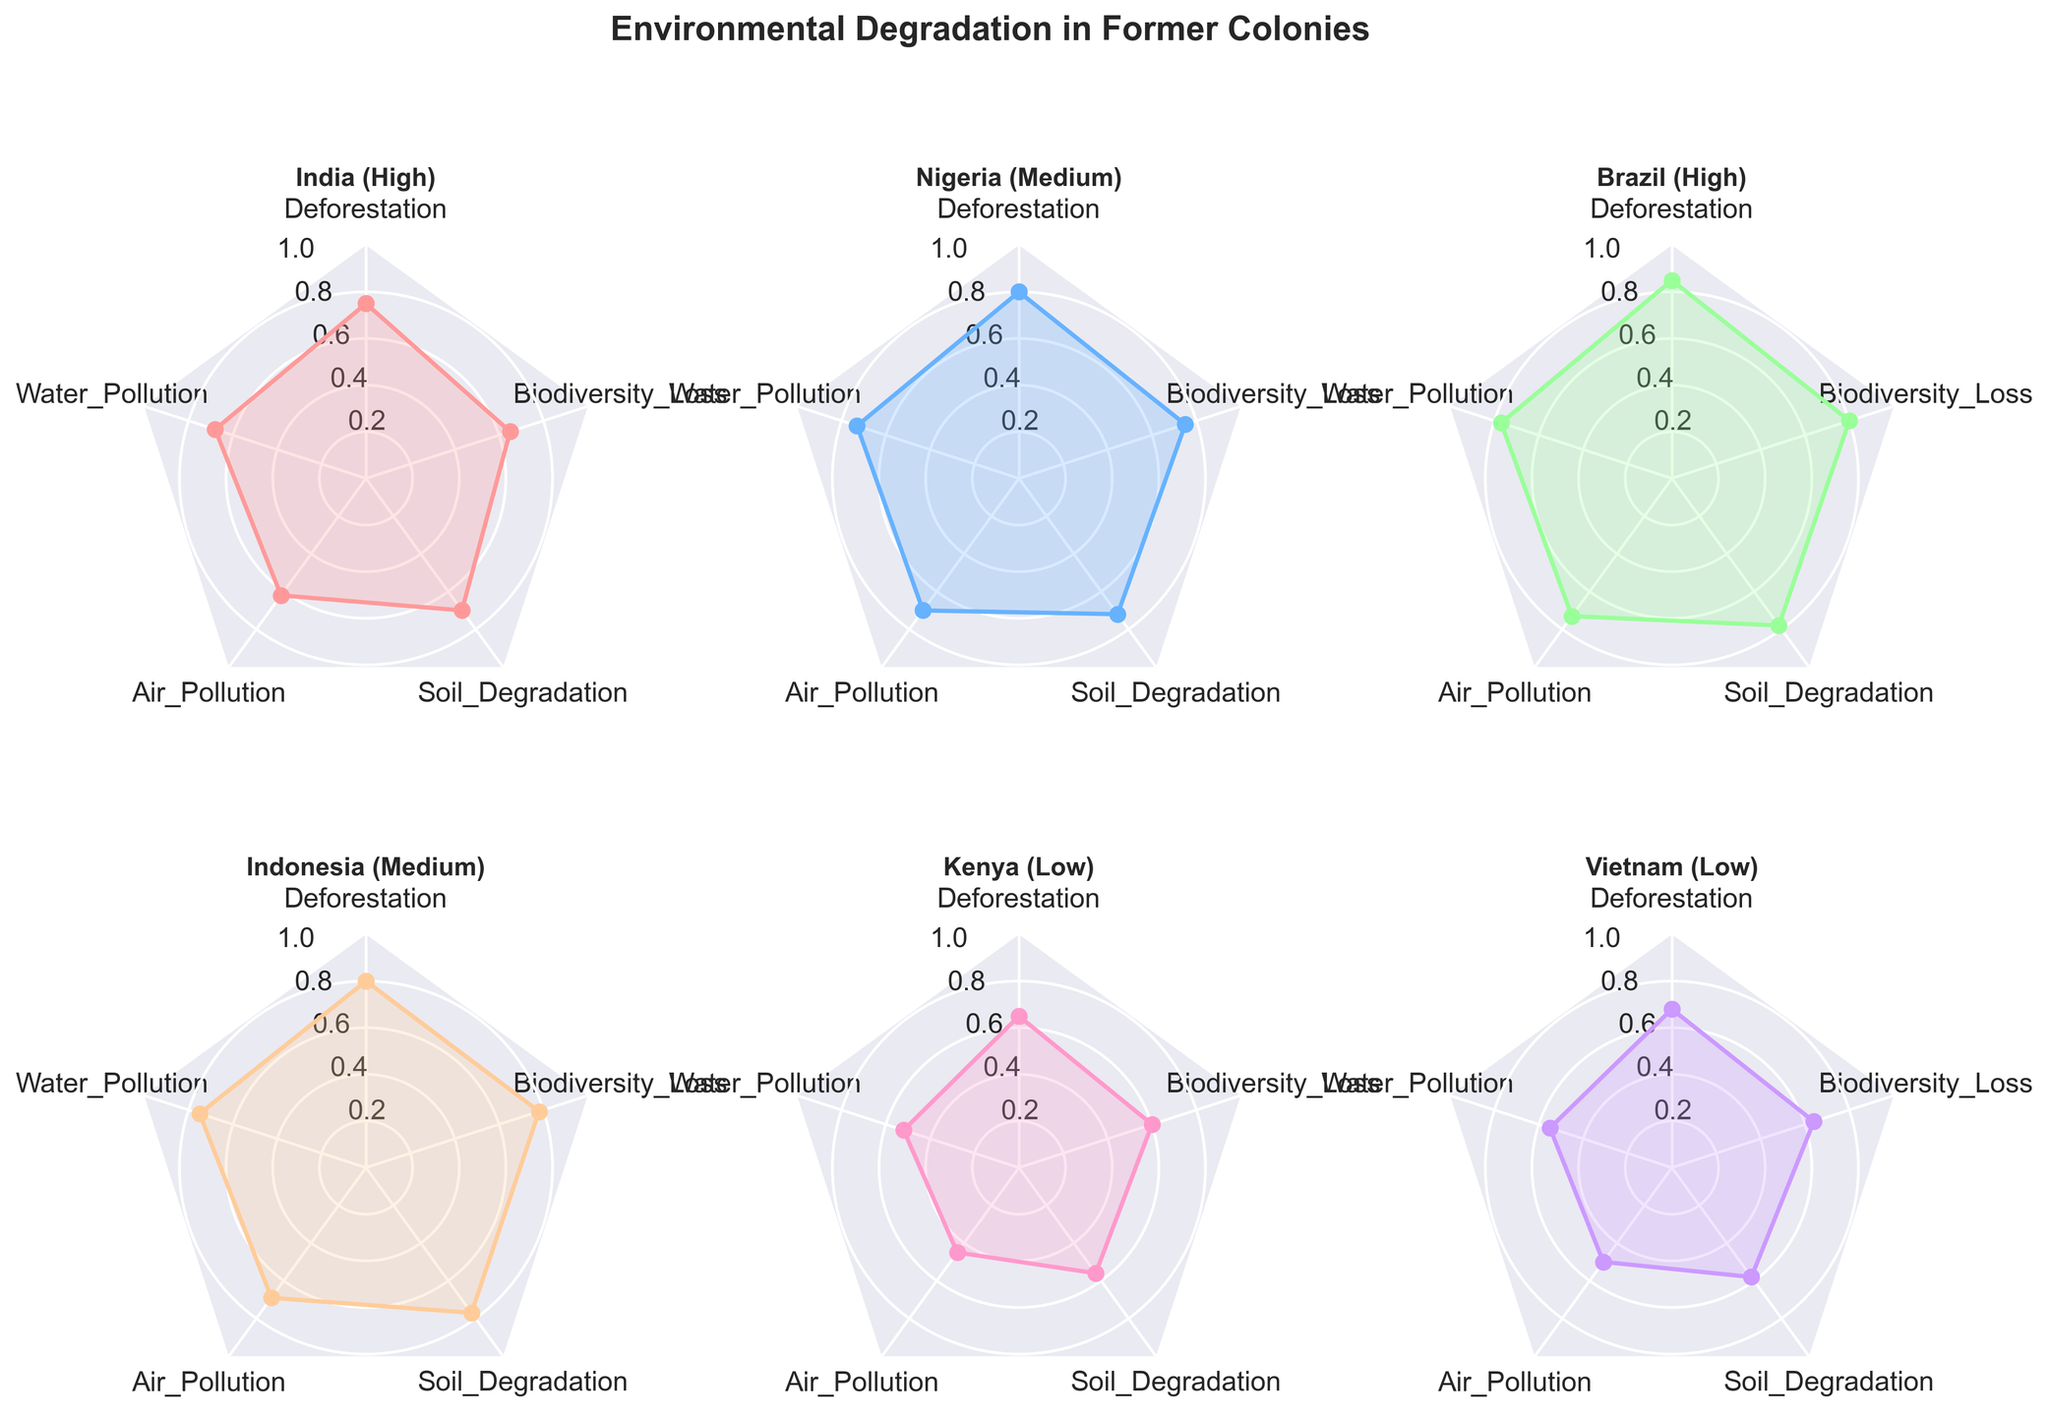Which country has the highest deforestation level? By observing the segments labeled "Deforestation" in the radar charts, the segment with the highest value indicates the highest deforestation level. Brazil has the highest deforestation level at 0.85.
Answer: Brazil Which country and industrialization level combination shows the lowest air pollution levels? Viewing the "Air Pollution" segments across all subplots, Kenya (Low) has the lowest value at 0.45.
Answer: Kenya (Low) What is the average water pollution level for high industrialization level countries? Both India and Brazil are classified under high industrialization. By averaging their water pollution values: (0.68 + 0.77) / 2 = 0.725.
Answer: 0.725 Which country has greater soil degradation, Indonesia or Vietnam? By checking the "Soil Degradation" segments of Indonesia and Vietnam, Indonesia has a higher value at 0.77 compared to Vietnam's 0.58.
Answer: Indonesia Which type of environmental degradation appears most consistently across all countries? By examining the amplitude across all categories in each radar chart, biodiversity loss often shows high values, being consistently problematic across all countries.
Answer: Biodiversity Loss Which country exhibits the widest range between its highest and lowest environmental degradation values? By calculating the range (difference between the highest and lowest values) for each country:
India: 0.75 - 0.62 = 0.13
Nigeria: 0.80 - 0.70 = 0.10
Brazil: 0.85 - 0.73 = 0.12
Indonesia: 0.80 - 0.69 = 0.11
Kenya: 0.65 - 0.45 = 0.20
Vietnam: 0.68 - 0.50 = 0.18
Kenya exhibits the widest range at 0.20.
Answer: Kenya Which industrialization level has the highest average deforestation level? Grouping countries by their industrialization level and averaging their deforestation values:
High: (0.75 + 0.85) / 2 = 0.80
Medium: (0.80 + 0.80) / 2 = 0.80
Low: (0.65 + 0.68) / 2 = 0.665
Both high and medium levels have the highest average deforestation level at 0.80.
Answer: High & Medium How does Kenya's air pollution value compare to that of other low industrialization countries? Comparing Kenya's air pollution value (0.45) with that of Vietnam (0.50), Kenya has a lower air pollution level.
Answer: Lower 